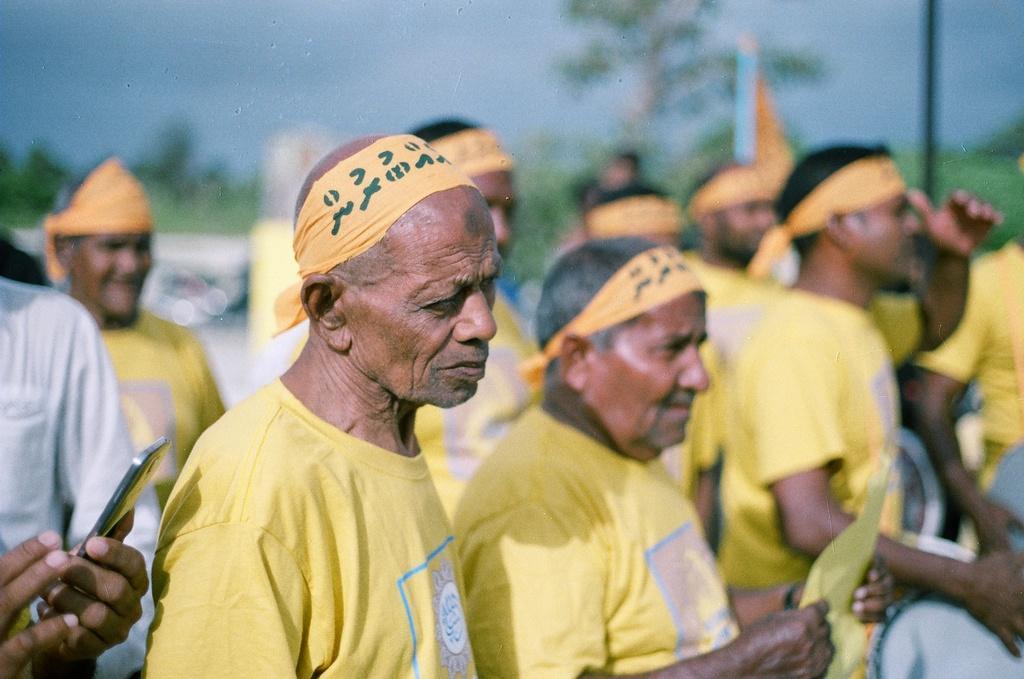How would you summarize this image in a sentence or two? In this image we can see a few people, among them some people are holding the objects, there are some trees, plants, pole and a flag, in the background we can see the sky. 